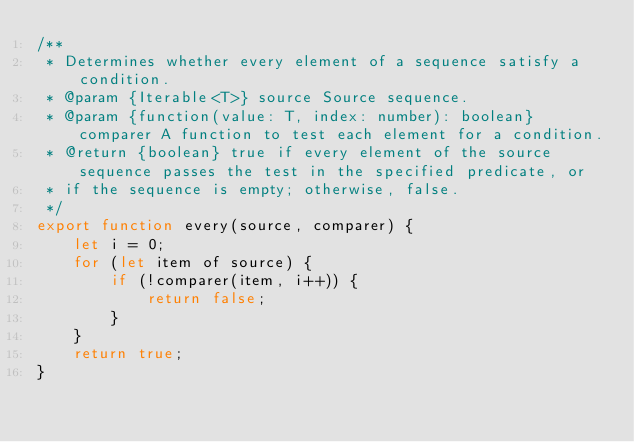<code> <loc_0><loc_0><loc_500><loc_500><_JavaScript_>/**
 * Determines whether every element of a sequence satisfy a condition.
 * @param {Iterable<T>} source Source sequence.
 * @param {function(value: T, index: number): boolean} comparer A function to test each element for a condition.
 * @return {boolean} true if every element of the source sequence passes the test in the specified predicate, or
 * if the sequence is empty; otherwise, false.
 */
export function every(source, comparer) {
    let i = 0;
    for (let item of source) {
        if (!comparer(item, i++)) {
            return false;
        }
    }
    return true;
}
</code> 